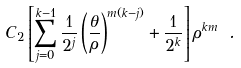Convert formula to latex. <formula><loc_0><loc_0><loc_500><loc_500>C _ { 2 } \left [ \sum _ { j = 0 } ^ { k - 1 } \frac { 1 } { 2 ^ { j } } \left ( \frac { \theta } { \rho } \right ) ^ { m ( k - j ) } + \frac { 1 } { 2 ^ { k } } \right ] \rho ^ { k m } \ .</formula> 